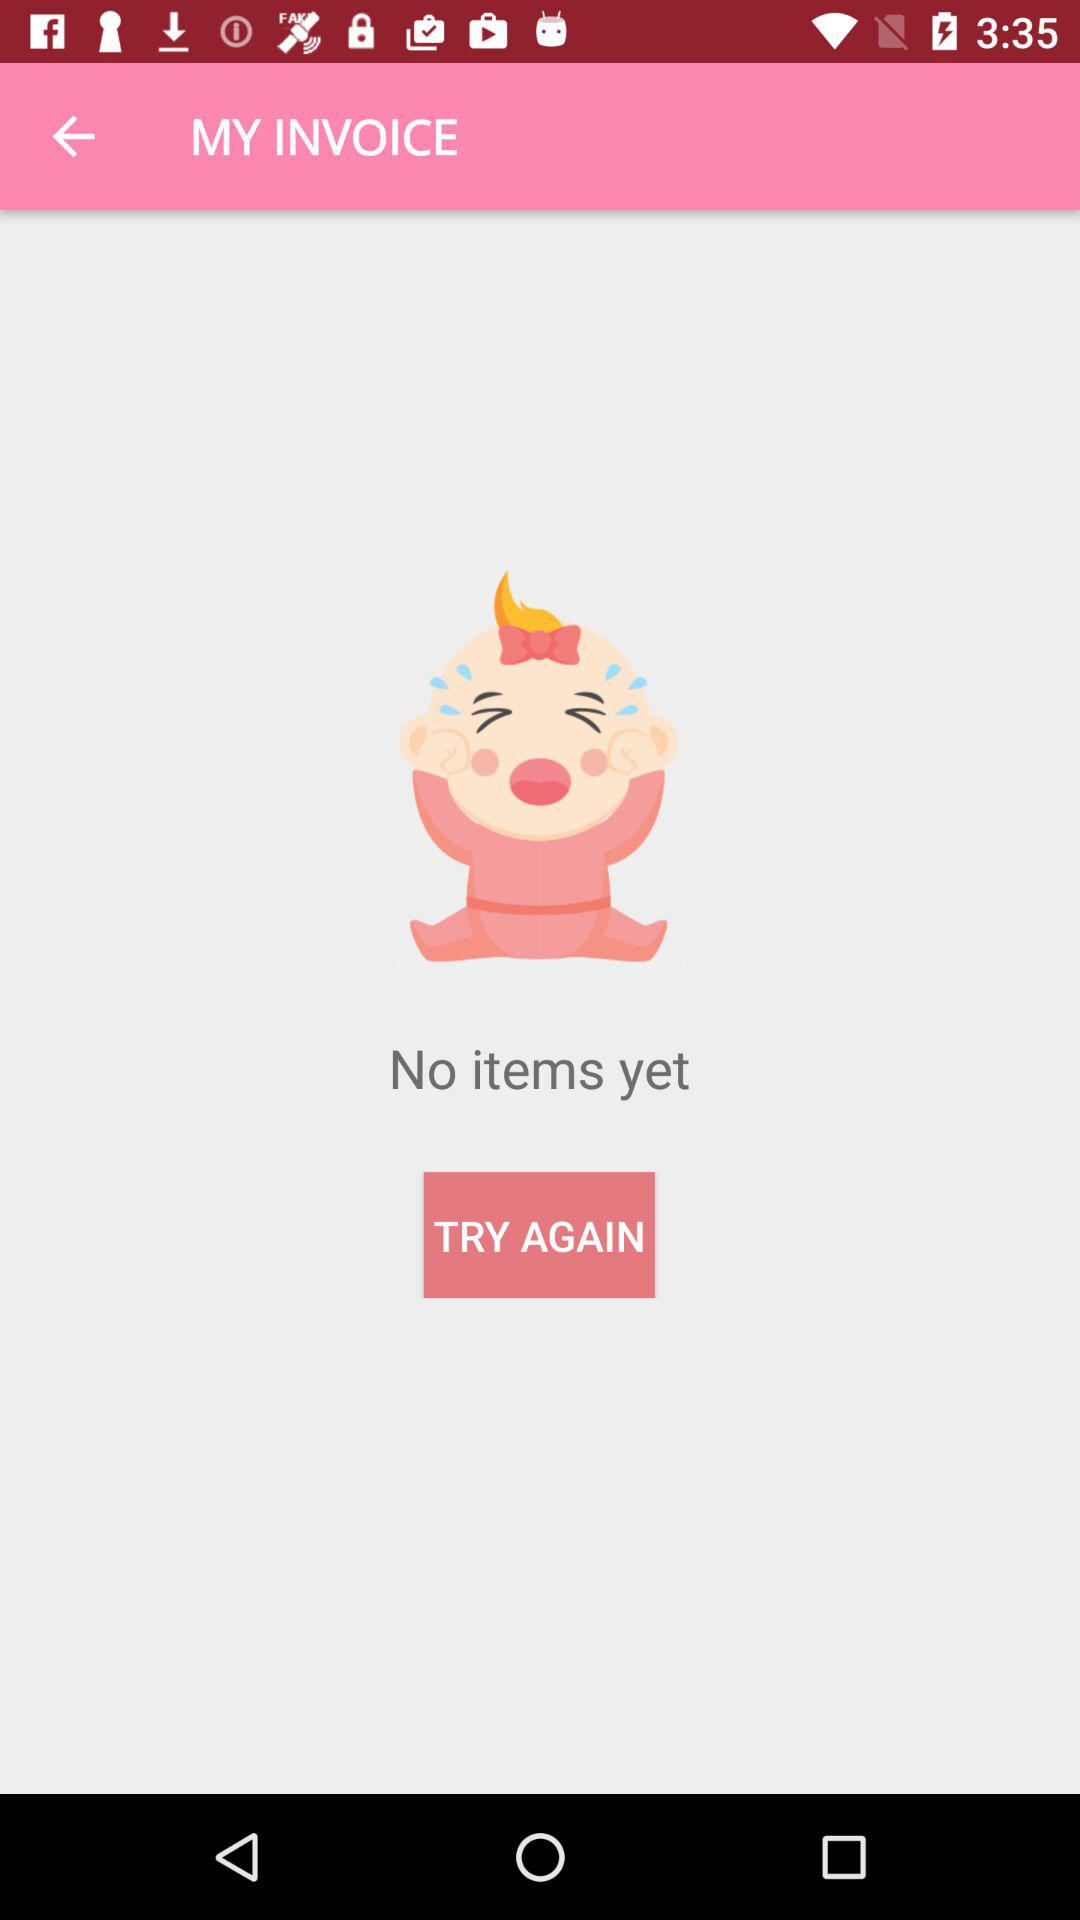How many items are there?
Answer the question using a single word or phrase. 0 